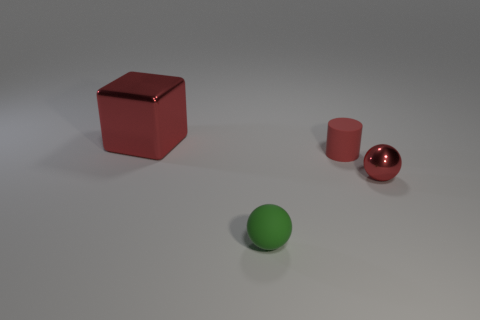Add 4 large yellow spheres. How many objects exist? 8 Subtract all cylinders. How many objects are left? 3 Subtract all large yellow rubber balls. Subtract all green objects. How many objects are left? 3 Add 2 metal blocks. How many metal blocks are left? 3 Add 1 matte spheres. How many matte spheres exist? 2 Subtract 0 brown cylinders. How many objects are left? 4 